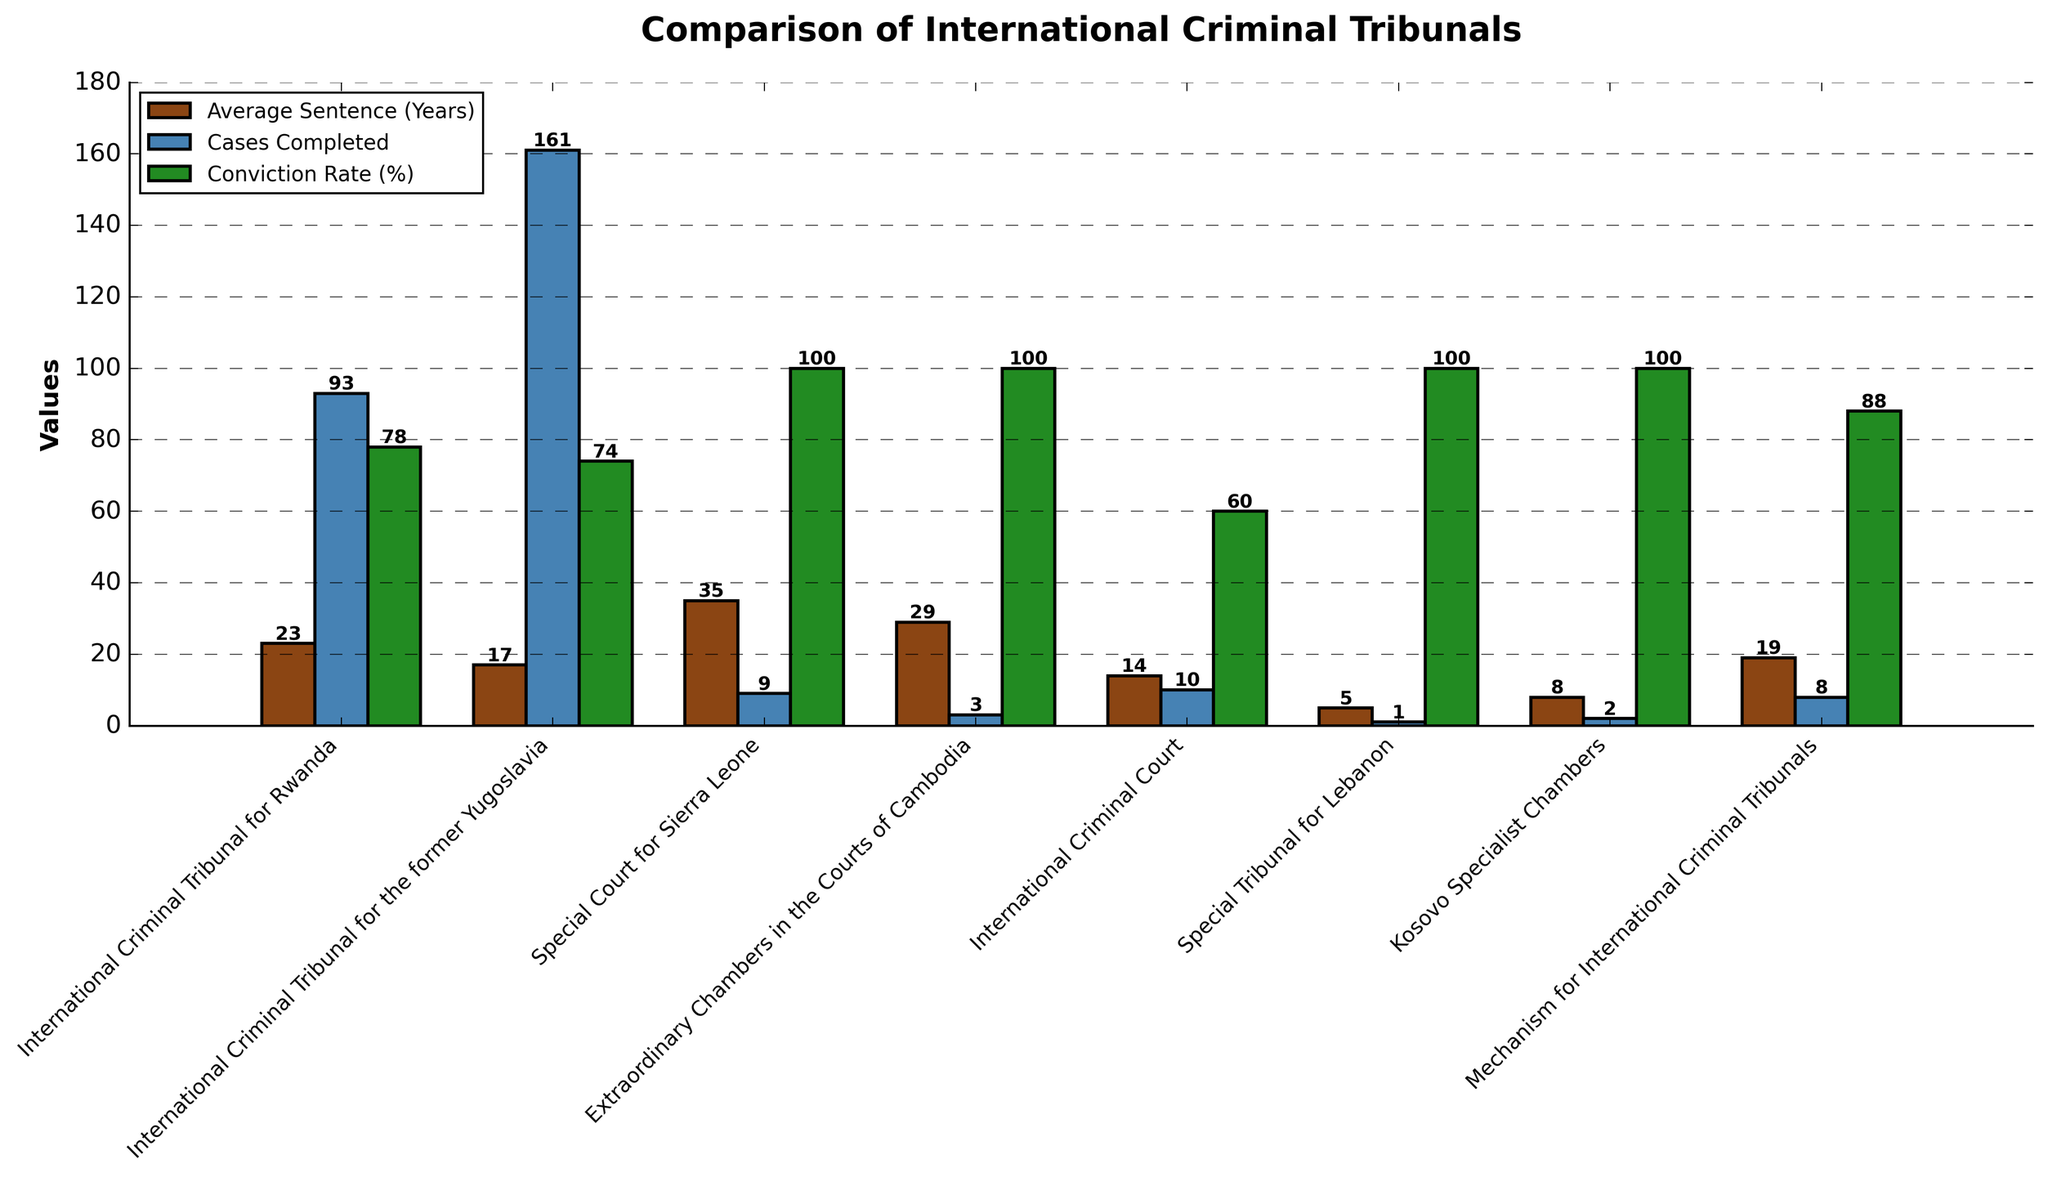Which tribunal has the highest average sentence? Reviewing the bar heights for 'Average Sentence (Years)', the Special Court for Sierra Leone has the tallest bar, indicating the highest average sentence.
Answer: Special Court for Sierra Leone How many tribunals have a 100% conviction rate? By observing the green bars labeled 'Conviction Rate (%)', count those that reach the highest point on the y-axis (100%). There are 5 such tribunals.
Answer: 5 Which tribunal has the smallest number of cases completed? Look at the blue bars labeled 'Cases Completed' and identify the shortest bar. The bar for the Special Tribunal for Lebanon is the shortest.
Answer: Special Tribunal for Lebanon What is the difference in the average sentence between the International Criminal Tribunal for Rwanda and the International Criminal Court? The average sentence for the International Criminal Tribunal for Rwanda is 23 years and for the International Criminal Court is 14 years. The difference is 23 - 14.
Answer: 9 years Which two tribunals have exactly the same conviction rate? Look at the green bars for 'Conviction Rate (%)' to find bars of the same height. The Special Court for Sierra Leone and the Extraordinary Chambers in the Courts of Cambodia both reach 100%.
Answer: Special Court for Sierra Leone and Extraordinary Chambers in the Courts of Cambodia What is the combined total of cases completed by the International Criminal Tribunal for the former Yugoslavia and the International Criminal Tribunal for Rwanda? The International Criminal Tribunal for the former Yugoslavia has 161 cases and the International Criminal Tribunal for Rwanda has 93 cases. The total is 161 + 93.
Answer: 254 cases Which tribunal has the lowest conviction rate? Comparing the heights of the green bars for 'Conviction Rate (%)', the International Criminal Court has the shortest bar, indicating the lowest rate.
Answer: International Criminal Court By how much does the Mechanism for International Criminal Tribunals' conviction rate exceed that of the International Criminal Court? The conviction rate for the Mechanism for International Criminal Tribunals is 88% and for the International Criminal Court it is 60%. The difference is 88 - 60.
Answer: 28% Among the tribunals with 100% conviction rate, which one has the greatest average sentence? Focus on the tribunals with green bars at the 100% mark. Compare their brown bars. The Special Court for Sierra Leone has the tallest brown bar, indicating the highest average sentence among them.
Answer: Special Court for Sierra Leone 